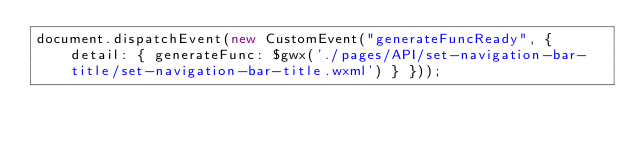Convert code to text. <code><loc_0><loc_0><loc_500><loc_500><_JavaScript_>document.dispatchEvent(new CustomEvent("generateFuncReady", { detail: { generateFunc: $gwx('./pages/API/set-navigation-bar-title/set-navigation-bar-title.wxml') } }));</code> 